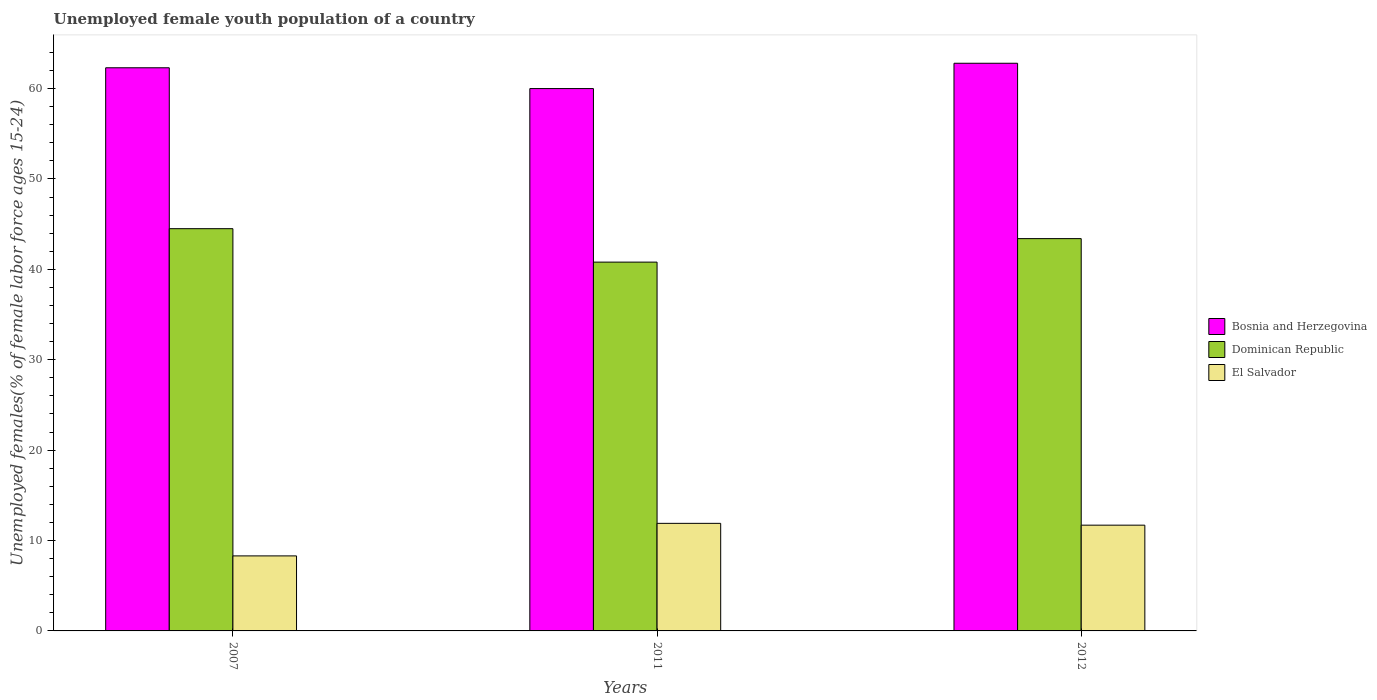How many bars are there on the 1st tick from the left?
Provide a short and direct response. 3. How many bars are there on the 1st tick from the right?
Your answer should be compact. 3. In how many cases, is the number of bars for a given year not equal to the number of legend labels?
Offer a terse response. 0. What is the percentage of unemployed female youth population in El Salvador in 2007?
Your response must be concise. 8.3. Across all years, what is the maximum percentage of unemployed female youth population in El Salvador?
Offer a terse response. 11.9. Across all years, what is the minimum percentage of unemployed female youth population in Dominican Republic?
Give a very brief answer. 40.8. In which year was the percentage of unemployed female youth population in Bosnia and Herzegovina maximum?
Ensure brevity in your answer.  2012. What is the total percentage of unemployed female youth population in Dominican Republic in the graph?
Make the answer very short. 128.7. What is the difference between the percentage of unemployed female youth population in Bosnia and Herzegovina in 2011 and that in 2012?
Keep it short and to the point. -2.8. What is the difference between the percentage of unemployed female youth population in Dominican Republic in 2007 and the percentage of unemployed female youth population in Bosnia and Herzegovina in 2012?
Offer a terse response. -18.3. What is the average percentage of unemployed female youth population in El Salvador per year?
Offer a very short reply. 10.63. In the year 2012, what is the difference between the percentage of unemployed female youth population in Bosnia and Herzegovina and percentage of unemployed female youth population in El Salvador?
Keep it short and to the point. 51.1. In how many years, is the percentage of unemployed female youth population in Bosnia and Herzegovina greater than 44 %?
Provide a succinct answer. 3. What is the ratio of the percentage of unemployed female youth population in El Salvador in 2011 to that in 2012?
Your answer should be very brief. 1.02. What is the difference between the highest and the second highest percentage of unemployed female youth population in El Salvador?
Give a very brief answer. 0.2. What is the difference between the highest and the lowest percentage of unemployed female youth population in El Salvador?
Your answer should be very brief. 3.6. In how many years, is the percentage of unemployed female youth population in Dominican Republic greater than the average percentage of unemployed female youth population in Dominican Republic taken over all years?
Give a very brief answer. 2. What does the 2nd bar from the left in 2007 represents?
Keep it short and to the point. Dominican Republic. What does the 2nd bar from the right in 2012 represents?
Provide a succinct answer. Dominican Republic. How many bars are there?
Your answer should be compact. 9. Does the graph contain any zero values?
Your answer should be very brief. No. Does the graph contain grids?
Ensure brevity in your answer.  No. How are the legend labels stacked?
Keep it short and to the point. Vertical. What is the title of the graph?
Provide a short and direct response. Unemployed female youth population of a country. What is the label or title of the Y-axis?
Keep it short and to the point. Unemployed females(% of female labor force ages 15-24). What is the Unemployed females(% of female labor force ages 15-24) in Bosnia and Herzegovina in 2007?
Offer a very short reply. 62.3. What is the Unemployed females(% of female labor force ages 15-24) in Dominican Republic in 2007?
Keep it short and to the point. 44.5. What is the Unemployed females(% of female labor force ages 15-24) in El Salvador in 2007?
Keep it short and to the point. 8.3. What is the Unemployed females(% of female labor force ages 15-24) of Dominican Republic in 2011?
Your answer should be very brief. 40.8. What is the Unemployed females(% of female labor force ages 15-24) in El Salvador in 2011?
Make the answer very short. 11.9. What is the Unemployed females(% of female labor force ages 15-24) in Bosnia and Herzegovina in 2012?
Your response must be concise. 62.8. What is the Unemployed females(% of female labor force ages 15-24) in Dominican Republic in 2012?
Give a very brief answer. 43.4. What is the Unemployed females(% of female labor force ages 15-24) in El Salvador in 2012?
Your answer should be very brief. 11.7. Across all years, what is the maximum Unemployed females(% of female labor force ages 15-24) of Bosnia and Herzegovina?
Your answer should be very brief. 62.8. Across all years, what is the maximum Unemployed females(% of female labor force ages 15-24) in Dominican Republic?
Your answer should be very brief. 44.5. Across all years, what is the maximum Unemployed females(% of female labor force ages 15-24) of El Salvador?
Offer a terse response. 11.9. Across all years, what is the minimum Unemployed females(% of female labor force ages 15-24) of Dominican Republic?
Ensure brevity in your answer.  40.8. Across all years, what is the minimum Unemployed females(% of female labor force ages 15-24) in El Salvador?
Provide a short and direct response. 8.3. What is the total Unemployed females(% of female labor force ages 15-24) of Bosnia and Herzegovina in the graph?
Keep it short and to the point. 185.1. What is the total Unemployed females(% of female labor force ages 15-24) of Dominican Republic in the graph?
Keep it short and to the point. 128.7. What is the total Unemployed females(% of female labor force ages 15-24) in El Salvador in the graph?
Keep it short and to the point. 31.9. What is the difference between the Unemployed females(% of female labor force ages 15-24) in Bosnia and Herzegovina in 2007 and that in 2011?
Offer a terse response. 2.3. What is the difference between the Unemployed females(% of female labor force ages 15-24) in El Salvador in 2007 and that in 2012?
Keep it short and to the point. -3.4. What is the difference between the Unemployed females(% of female labor force ages 15-24) of Bosnia and Herzegovina in 2011 and that in 2012?
Provide a short and direct response. -2.8. What is the difference between the Unemployed females(% of female labor force ages 15-24) of Dominican Republic in 2011 and that in 2012?
Provide a short and direct response. -2.6. What is the difference between the Unemployed females(% of female labor force ages 15-24) of Bosnia and Herzegovina in 2007 and the Unemployed females(% of female labor force ages 15-24) of Dominican Republic in 2011?
Keep it short and to the point. 21.5. What is the difference between the Unemployed females(% of female labor force ages 15-24) in Bosnia and Herzegovina in 2007 and the Unemployed females(% of female labor force ages 15-24) in El Salvador in 2011?
Your response must be concise. 50.4. What is the difference between the Unemployed females(% of female labor force ages 15-24) of Dominican Republic in 2007 and the Unemployed females(% of female labor force ages 15-24) of El Salvador in 2011?
Provide a succinct answer. 32.6. What is the difference between the Unemployed females(% of female labor force ages 15-24) of Bosnia and Herzegovina in 2007 and the Unemployed females(% of female labor force ages 15-24) of Dominican Republic in 2012?
Your response must be concise. 18.9. What is the difference between the Unemployed females(% of female labor force ages 15-24) in Bosnia and Herzegovina in 2007 and the Unemployed females(% of female labor force ages 15-24) in El Salvador in 2012?
Your answer should be very brief. 50.6. What is the difference between the Unemployed females(% of female labor force ages 15-24) in Dominican Republic in 2007 and the Unemployed females(% of female labor force ages 15-24) in El Salvador in 2012?
Ensure brevity in your answer.  32.8. What is the difference between the Unemployed females(% of female labor force ages 15-24) in Bosnia and Herzegovina in 2011 and the Unemployed females(% of female labor force ages 15-24) in El Salvador in 2012?
Your response must be concise. 48.3. What is the difference between the Unemployed females(% of female labor force ages 15-24) in Dominican Republic in 2011 and the Unemployed females(% of female labor force ages 15-24) in El Salvador in 2012?
Give a very brief answer. 29.1. What is the average Unemployed females(% of female labor force ages 15-24) in Bosnia and Herzegovina per year?
Your response must be concise. 61.7. What is the average Unemployed females(% of female labor force ages 15-24) of Dominican Republic per year?
Offer a terse response. 42.9. What is the average Unemployed females(% of female labor force ages 15-24) of El Salvador per year?
Keep it short and to the point. 10.63. In the year 2007, what is the difference between the Unemployed females(% of female labor force ages 15-24) in Bosnia and Herzegovina and Unemployed females(% of female labor force ages 15-24) in El Salvador?
Provide a succinct answer. 54. In the year 2007, what is the difference between the Unemployed females(% of female labor force ages 15-24) of Dominican Republic and Unemployed females(% of female labor force ages 15-24) of El Salvador?
Give a very brief answer. 36.2. In the year 2011, what is the difference between the Unemployed females(% of female labor force ages 15-24) of Bosnia and Herzegovina and Unemployed females(% of female labor force ages 15-24) of El Salvador?
Offer a very short reply. 48.1. In the year 2011, what is the difference between the Unemployed females(% of female labor force ages 15-24) in Dominican Republic and Unemployed females(% of female labor force ages 15-24) in El Salvador?
Your response must be concise. 28.9. In the year 2012, what is the difference between the Unemployed females(% of female labor force ages 15-24) of Bosnia and Herzegovina and Unemployed females(% of female labor force ages 15-24) of El Salvador?
Give a very brief answer. 51.1. In the year 2012, what is the difference between the Unemployed females(% of female labor force ages 15-24) of Dominican Republic and Unemployed females(% of female labor force ages 15-24) of El Salvador?
Your answer should be very brief. 31.7. What is the ratio of the Unemployed females(% of female labor force ages 15-24) of Bosnia and Herzegovina in 2007 to that in 2011?
Your answer should be very brief. 1.04. What is the ratio of the Unemployed females(% of female labor force ages 15-24) of Dominican Republic in 2007 to that in 2011?
Provide a short and direct response. 1.09. What is the ratio of the Unemployed females(% of female labor force ages 15-24) of El Salvador in 2007 to that in 2011?
Provide a short and direct response. 0.7. What is the ratio of the Unemployed females(% of female labor force ages 15-24) of Bosnia and Herzegovina in 2007 to that in 2012?
Provide a succinct answer. 0.99. What is the ratio of the Unemployed females(% of female labor force ages 15-24) in Dominican Republic in 2007 to that in 2012?
Offer a terse response. 1.03. What is the ratio of the Unemployed females(% of female labor force ages 15-24) of El Salvador in 2007 to that in 2012?
Make the answer very short. 0.71. What is the ratio of the Unemployed females(% of female labor force ages 15-24) of Bosnia and Herzegovina in 2011 to that in 2012?
Your response must be concise. 0.96. What is the ratio of the Unemployed females(% of female labor force ages 15-24) in Dominican Republic in 2011 to that in 2012?
Give a very brief answer. 0.94. What is the ratio of the Unemployed females(% of female labor force ages 15-24) in El Salvador in 2011 to that in 2012?
Keep it short and to the point. 1.02. What is the difference between the highest and the second highest Unemployed females(% of female labor force ages 15-24) of El Salvador?
Ensure brevity in your answer.  0.2. What is the difference between the highest and the lowest Unemployed females(% of female labor force ages 15-24) in El Salvador?
Your answer should be very brief. 3.6. 